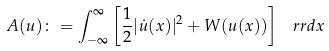Convert formula to latex. <formula><loc_0><loc_0><loc_500><loc_500>A ( u ) \colon = \int _ { - \infty } ^ { \infty } \left [ \frac { 1 } { 2 } | \dot { u } ( x ) | ^ { 2 } + W ( u ( x ) ) \right ] \, \ r r { d } x</formula> 